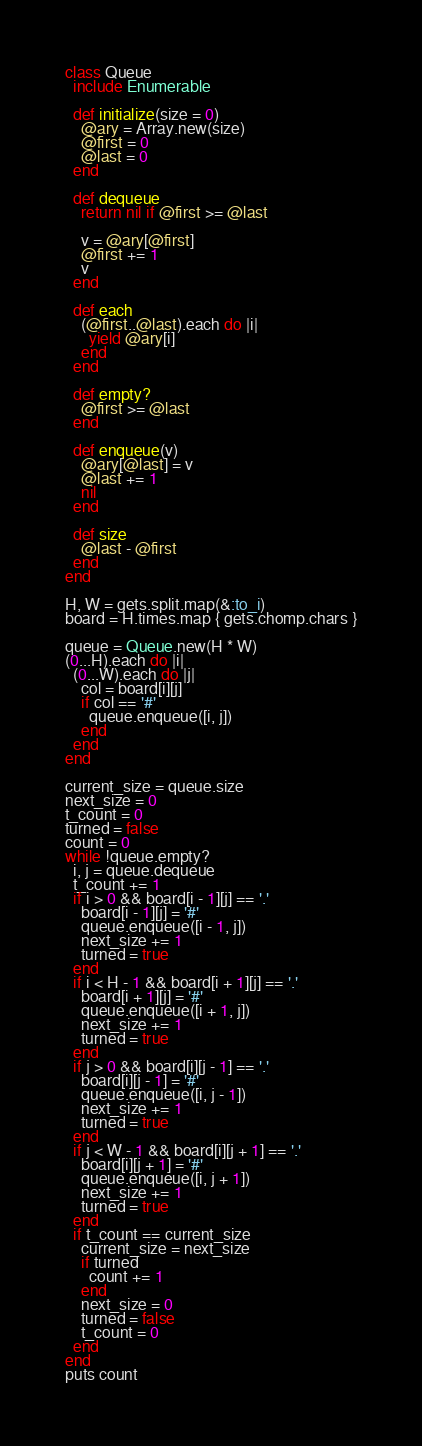Convert code to text. <code><loc_0><loc_0><loc_500><loc_500><_Ruby_>class Queue
  include Enumerable

  def initialize(size = 0)
    @ary = Array.new(size)
    @first = 0
    @last = 0
  end

  def dequeue
    return nil if @first >= @last

    v = @ary[@first]
    @first += 1
    v
  end

  def each
    (@first..@last).each do |i|
      yield @ary[i]
    end
  end

  def empty?
    @first >= @last
  end

  def enqueue(v)
    @ary[@last] = v
    @last += 1
    nil
  end

  def size
    @last - @first
  end
end

H, W = gets.split.map(&:to_i)
board = H.times.map { gets.chomp.chars }

queue = Queue.new(H * W)
(0...H).each do |i|
  (0...W).each do |j|
    col = board[i][j]
    if col == '#'
      queue.enqueue([i, j])
    end
  end
end

current_size = queue.size
next_size = 0
t_count = 0
turned = false
count = 0
while !queue.empty?
  i, j = queue.dequeue
  t_count += 1
  if i > 0 && board[i - 1][j] == '.'
    board[i - 1][j] = '#'
    queue.enqueue([i - 1, j])
    next_size += 1
    turned = true
  end
  if i < H - 1 && board[i + 1][j] == '.'
    board[i + 1][j] = '#'
    queue.enqueue([i + 1, j])
    next_size += 1
    turned = true
  end
  if j > 0 && board[i][j - 1] == '.'
    board[i][j - 1] = '#'
    queue.enqueue([i, j - 1])
    next_size += 1
    turned = true
  end
  if j < W - 1 && board[i][j + 1] == '.'
    board[i][j + 1] = '#'
    queue.enqueue([i, j + 1])
    next_size += 1
    turned = true
  end
  if t_count == current_size
    current_size = next_size
    if turned
      count += 1
    end
    next_size = 0
    turned = false
    t_count = 0
  end
end
puts count
</code> 